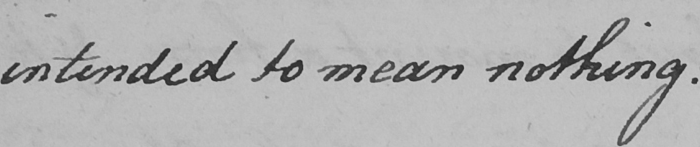What text is written in this handwritten line? intended to mean nothing . 